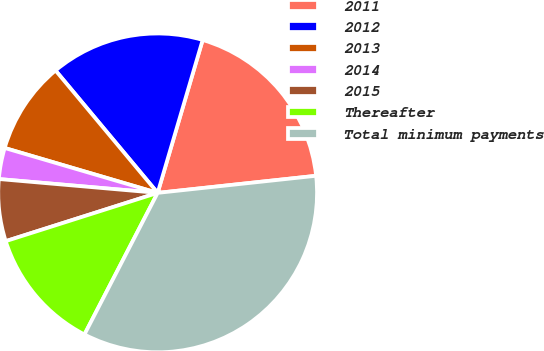Convert chart to OTSL. <chart><loc_0><loc_0><loc_500><loc_500><pie_chart><fcel>2011<fcel>2012<fcel>2013<fcel>2014<fcel>2015<fcel>Thereafter<fcel>Total minimum payments<nl><fcel>18.73%<fcel>15.62%<fcel>9.39%<fcel>3.16%<fcel>6.28%<fcel>12.51%<fcel>34.3%<nl></chart> 